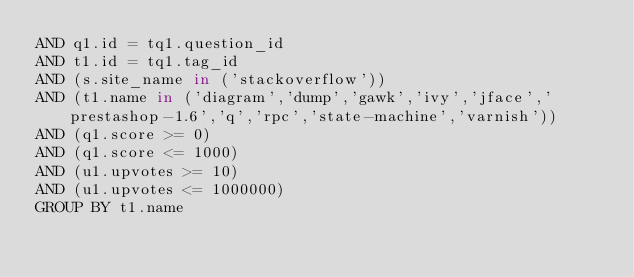<code> <loc_0><loc_0><loc_500><loc_500><_SQL_>AND q1.id = tq1.question_id
AND t1.id = tq1.tag_id
AND (s.site_name in ('stackoverflow'))
AND (t1.name in ('diagram','dump','gawk','ivy','jface','prestashop-1.6','q','rpc','state-machine','varnish'))
AND (q1.score >= 0)
AND (q1.score <= 1000)
AND (u1.upvotes >= 10)
AND (u1.upvotes <= 1000000)
GROUP BY t1.name</code> 